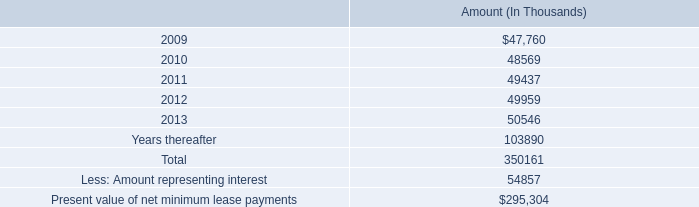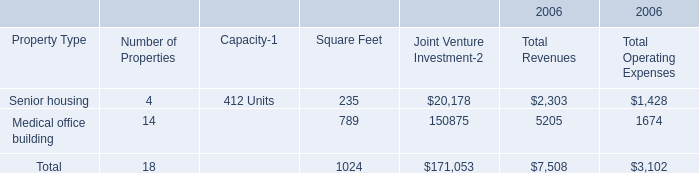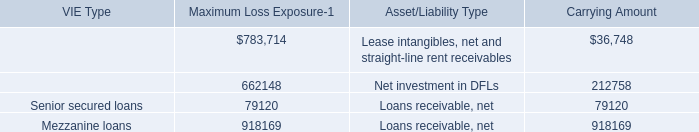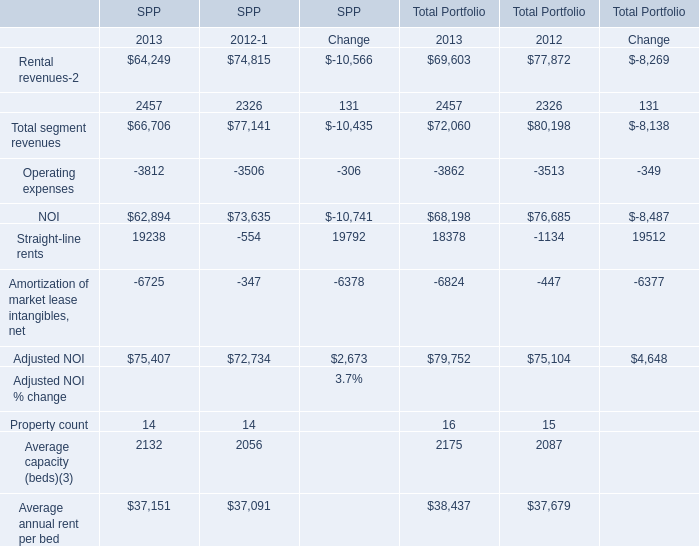What's the average of Average annual rent per bed of SPP 2013, and Mezzanine loans of Carrying Amount ? 
Computations: ((37151.0 + 918169.0) / 2)
Answer: 477660.0. 